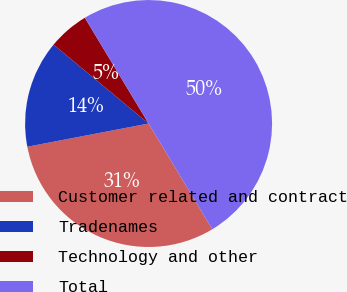Convert chart. <chart><loc_0><loc_0><loc_500><loc_500><pie_chart><fcel>Customer related and contract<fcel>Tradenames<fcel>Technology and other<fcel>Total<nl><fcel>30.62%<fcel>14.04%<fcel>5.34%<fcel>50.0%<nl></chart> 